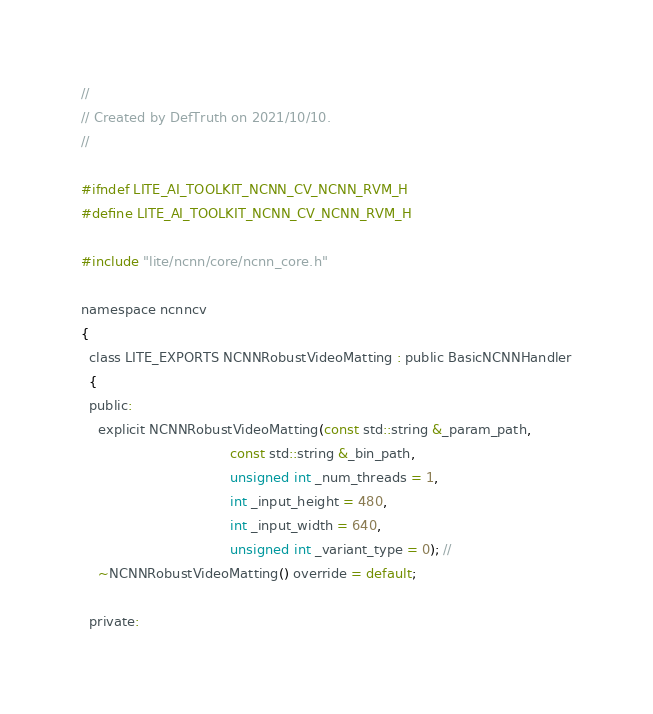Convert code to text. <code><loc_0><loc_0><loc_500><loc_500><_C_>//
// Created by DefTruth on 2021/10/10.
//

#ifndef LITE_AI_TOOLKIT_NCNN_CV_NCNN_RVM_H
#define LITE_AI_TOOLKIT_NCNN_CV_NCNN_RVM_H

#include "lite/ncnn/core/ncnn_core.h"

namespace ncnncv
{
  class LITE_EXPORTS NCNNRobustVideoMatting : public BasicNCNNHandler
  {
  public:
    explicit NCNNRobustVideoMatting(const std::string &_param_path,
                                    const std::string &_bin_path,
                                    unsigned int _num_threads = 1,
                                    int _input_height = 480,
                                    int _input_width = 640,
                                    unsigned int _variant_type = 0); //
    ~NCNNRobustVideoMatting() override = default;

  private:</code> 